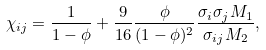Convert formula to latex. <formula><loc_0><loc_0><loc_500><loc_500>\chi _ { i j } = \frac { 1 } { 1 - \phi } + \frac { 9 } { 1 6 } \frac { \phi } { ( 1 - \phi ) ^ { 2 } } \frac { \sigma _ { i } \sigma _ { j } M _ { 1 } } { \sigma _ { i j } M _ { 2 } } ,</formula> 